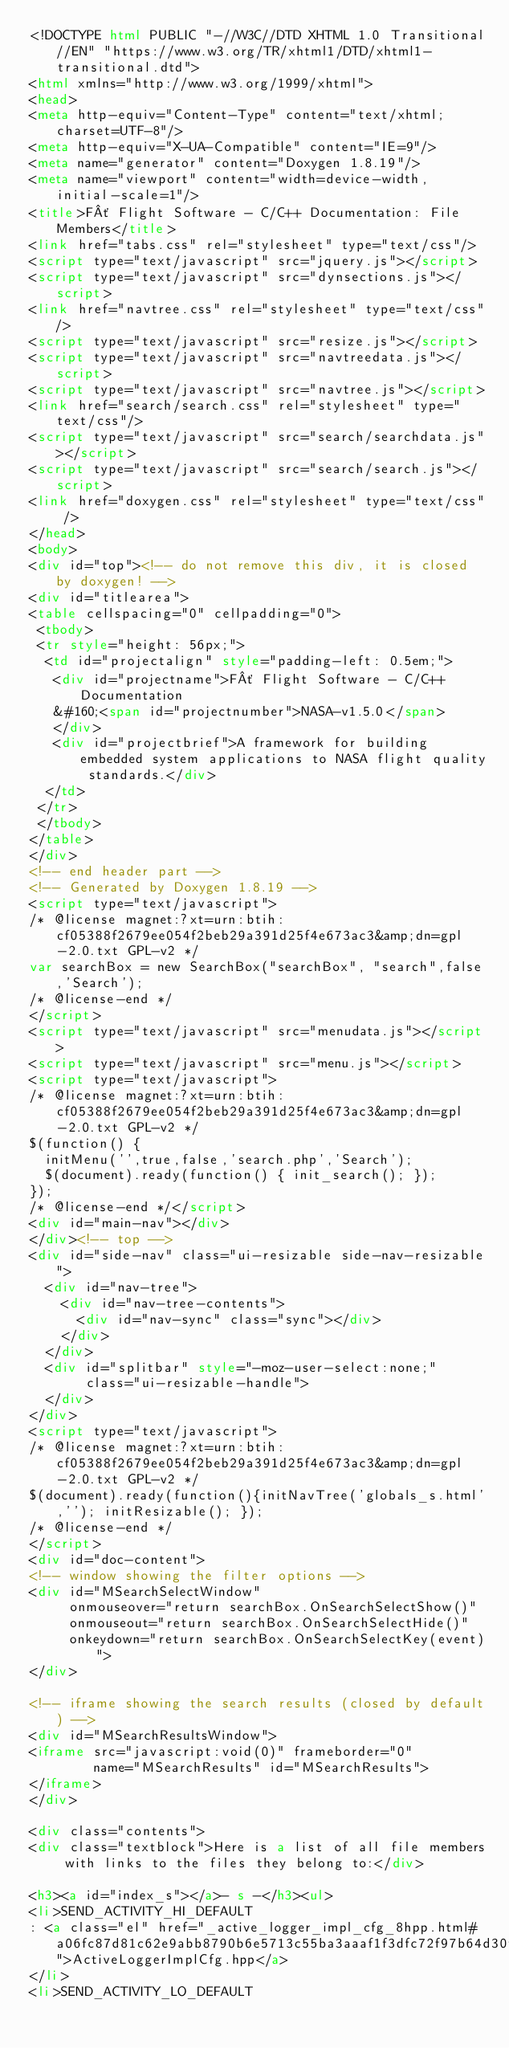Convert code to text. <code><loc_0><loc_0><loc_500><loc_500><_HTML_><!DOCTYPE html PUBLIC "-//W3C//DTD XHTML 1.0 Transitional//EN" "https://www.w3.org/TR/xhtml1/DTD/xhtml1-transitional.dtd">
<html xmlns="http://www.w3.org/1999/xhtml">
<head>
<meta http-equiv="Content-Type" content="text/xhtml;charset=UTF-8"/>
<meta http-equiv="X-UA-Compatible" content="IE=9"/>
<meta name="generator" content="Doxygen 1.8.19"/>
<meta name="viewport" content="width=device-width, initial-scale=1"/>
<title>F´ Flight Software - C/C++ Documentation: File Members</title>
<link href="tabs.css" rel="stylesheet" type="text/css"/>
<script type="text/javascript" src="jquery.js"></script>
<script type="text/javascript" src="dynsections.js"></script>
<link href="navtree.css" rel="stylesheet" type="text/css"/>
<script type="text/javascript" src="resize.js"></script>
<script type="text/javascript" src="navtreedata.js"></script>
<script type="text/javascript" src="navtree.js"></script>
<link href="search/search.css" rel="stylesheet" type="text/css"/>
<script type="text/javascript" src="search/searchdata.js"></script>
<script type="text/javascript" src="search/search.js"></script>
<link href="doxygen.css" rel="stylesheet" type="text/css" />
</head>
<body>
<div id="top"><!-- do not remove this div, it is closed by doxygen! -->
<div id="titlearea">
<table cellspacing="0" cellpadding="0">
 <tbody>
 <tr style="height: 56px;">
  <td id="projectalign" style="padding-left: 0.5em;">
   <div id="projectname">F´ Flight Software - C/C++ Documentation
   &#160;<span id="projectnumber">NASA-v1.5.0</span>
   </div>
   <div id="projectbrief">A framework for building embedded system applications to NASA flight quality standards.</div>
  </td>
 </tr>
 </tbody>
</table>
</div>
<!-- end header part -->
<!-- Generated by Doxygen 1.8.19 -->
<script type="text/javascript">
/* @license magnet:?xt=urn:btih:cf05388f2679ee054f2beb29a391d25f4e673ac3&amp;dn=gpl-2.0.txt GPL-v2 */
var searchBox = new SearchBox("searchBox", "search",false,'Search');
/* @license-end */
</script>
<script type="text/javascript" src="menudata.js"></script>
<script type="text/javascript" src="menu.js"></script>
<script type="text/javascript">
/* @license magnet:?xt=urn:btih:cf05388f2679ee054f2beb29a391d25f4e673ac3&amp;dn=gpl-2.0.txt GPL-v2 */
$(function() {
  initMenu('',true,false,'search.php','Search');
  $(document).ready(function() { init_search(); });
});
/* @license-end */</script>
<div id="main-nav"></div>
</div><!-- top -->
<div id="side-nav" class="ui-resizable side-nav-resizable">
  <div id="nav-tree">
    <div id="nav-tree-contents">
      <div id="nav-sync" class="sync"></div>
    </div>
  </div>
  <div id="splitbar" style="-moz-user-select:none;" 
       class="ui-resizable-handle">
  </div>
</div>
<script type="text/javascript">
/* @license magnet:?xt=urn:btih:cf05388f2679ee054f2beb29a391d25f4e673ac3&amp;dn=gpl-2.0.txt GPL-v2 */
$(document).ready(function(){initNavTree('globals_s.html',''); initResizable(); });
/* @license-end */
</script>
<div id="doc-content">
<!-- window showing the filter options -->
<div id="MSearchSelectWindow"
     onmouseover="return searchBox.OnSearchSelectShow()"
     onmouseout="return searchBox.OnSearchSelectHide()"
     onkeydown="return searchBox.OnSearchSelectKey(event)">
</div>

<!-- iframe showing the search results (closed by default) -->
<div id="MSearchResultsWindow">
<iframe src="javascript:void(0)" frameborder="0" 
        name="MSearchResults" id="MSearchResults">
</iframe>
</div>

<div class="contents">
<div class="textblock">Here is a list of all file members with links to the files they belong to:</div>

<h3><a id="index_s"></a>- s -</h3><ul>
<li>SEND_ACTIVITY_HI_DEFAULT
: <a class="el" href="_active_logger_impl_cfg_8hpp.html#a06fc87d81c62e9abb8790b6e5713c55ba3aaaf1f3dfc72f97b64d30f6c0bdbffe">ActiveLoggerImplCfg.hpp</a>
</li>
<li>SEND_ACTIVITY_LO_DEFAULT</code> 